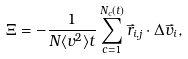Convert formula to latex. <formula><loc_0><loc_0><loc_500><loc_500>\Xi = - \frac { 1 } { N \langle v ^ { 2 } \rangle t } \sum _ { c = 1 } ^ { N _ { c } ( t ) } \vec { r } _ { i , j } \cdot \Delta \vec { v } _ { i } ,</formula> 